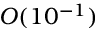<formula> <loc_0><loc_0><loc_500><loc_500>O ( 1 0 ^ { - 1 } )</formula> 